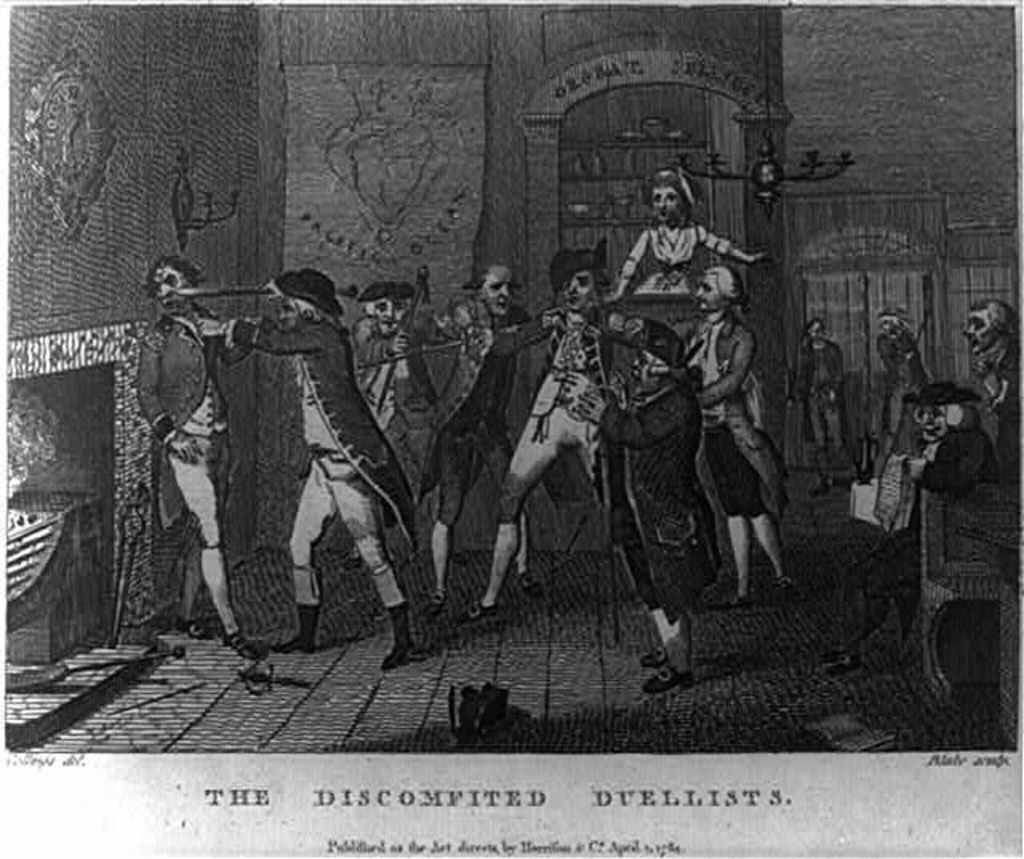How would you summarize this image in a sentence or two? In this picture we can see poster, on this poster we can see people. At the bottom of the image we can see text. 